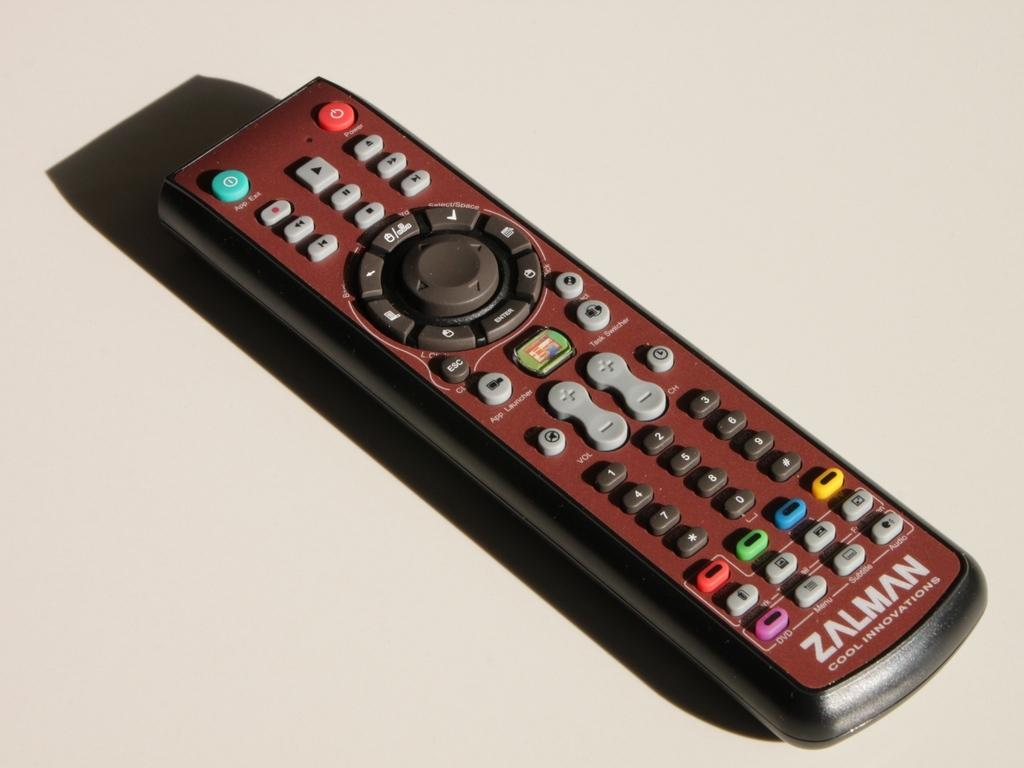<image>
Give a short and clear explanation of the subsequent image. A remote control is marked with Zalman Cool Innovations. 